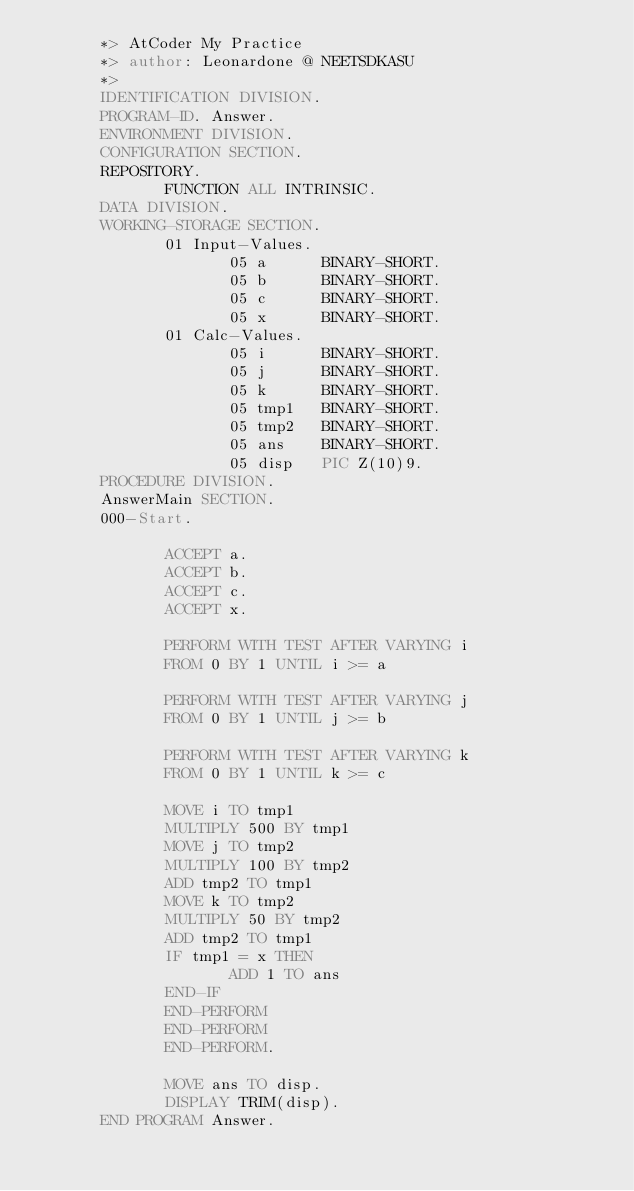Convert code to text. <code><loc_0><loc_0><loc_500><loc_500><_COBOL_>       *> AtCoder My Practice
       *> author: Leonardone @ NEETSDKASU
       *>
       IDENTIFICATION DIVISION.
       PROGRAM-ID. Answer.
       ENVIRONMENT DIVISION.
       CONFIGURATION SECTION.
       REPOSITORY.
              FUNCTION ALL INTRINSIC.
       DATA DIVISION.
       WORKING-STORAGE SECTION.
              01 Input-Values.
                     05 a      BINARY-SHORT.
                     05 b      BINARY-SHORT.
                     05 c      BINARY-SHORT.
                     05 x      BINARY-SHORT.
              01 Calc-Values.
                     05 i      BINARY-SHORT.
                     05 j      BINARY-SHORT.
                     05 k      BINARY-SHORT.
                     05 tmp1   BINARY-SHORT.
                     05 tmp2   BINARY-SHORT.
                     05 ans    BINARY-SHORT.
                     05 disp   PIC Z(10)9.
       PROCEDURE DIVISION.
       AnswerMain SECTION.
       000-Start.
       
              ACCEPT a.
              ACCEPT b.
              ACCEPT c.
              ACCEPT x.
              
              PERFORM WITH TEST AFTER VARYING i
              FROM 0 BY 1 UNTIL i >= a
      
              PERFORM WITH TEST AFTER VARYING j
              FROM 0 BY 1 UNTIL j >= b

              PERFORM WITH TEST AFTER VARYING k
              FROM 0 BY 1 UNTIL k >= c
              
              MOVE i TO tmp1
              MULTIPLY 500 BY tmp1
              MOVE j TO tmp2
              MULTIPLY 100 BY tmp2
              ADD tmp2 TO tmp1
              MOVE k TO tmp2
              MULTIPLY 50 BY tmp2
              ADD tmp2 TO tmp1
              IF tmp1 = x THEN
                     ADD 1 TO ans
              END-IF
              END-PERFORM
              END-PERFORM
              END-PERFORM.
               
              MOVE ans TO disp.
              DISPLAY TRIM(disp).
       END PROGRAM Answer.
</code> 